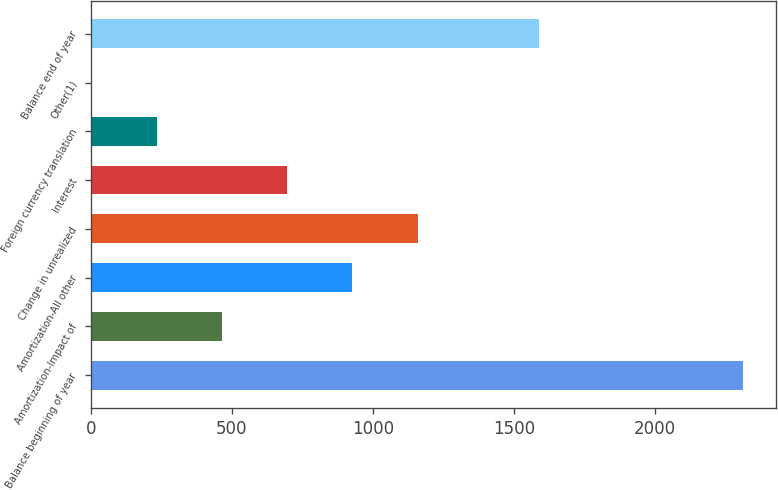<chart> <loc_0><loc_0><loc_500><loc_500><bar_chart><fcel>Balance beginning of year<fcel>Amortization-Impact of<fcel>Amortization-All other<fcel>Change in unrealized<fcel>Interest<fcel>Foreign currency translation<fcel>Other(1)<fcel>Balance end of year<nl><fcel>2314<fcel>465.75<fcel>927.81<fcel>1158.84<fcel>696.78<fcel>234.72<fcel>3.69<fcel>1591<nl></chart> 